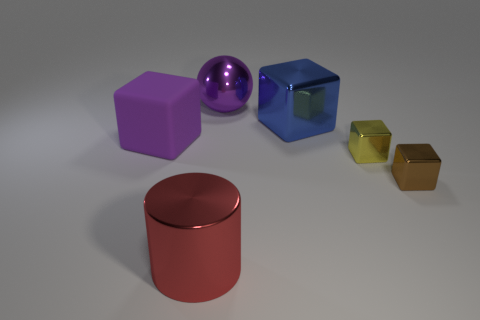What is the purple object that is to the right of the purple matte object made of?
Offer a terse response. Metal. Are there fewer tiny yellow metal things than tiny red things?
Provide a short and direct response. No. What shape is the large thing that is both in front of the large blue metal object and behind the big red object?
Offer a very short reply. Cube. How many small cylinders are there?
Make the answer very short. 0. There is a big block that is in front of the large cube right of the big cube on the left side of the cylinder; what is it made of?
Your response must be concise. Rubber. What number of metallic balls are in front of the big thing on the left side of the large red cylinder?
Offer a terse response. 0. What is the color of the other large object that is the same shape as the blue thing?
Provide a short and direct response. Purple. Is the material of the large red cylinder the same as the purple block?
Give a very brief answer. No. What number of cubes are either red matte things or big blue objects?
Give a very brief answer. 1. There is a purple thing that is in front of the large purple thing to the right of the purple thing that is on the left side of the big red metallic thing; what is its size?
Your response must be concise. Large. 